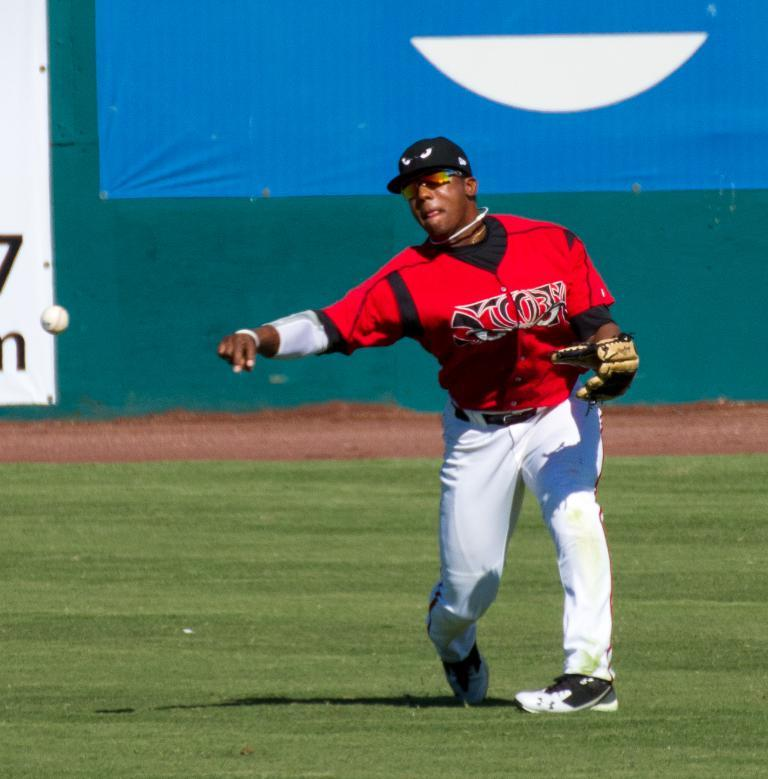What is the main subject of the image? There is a baseball player in the image. What is the baseball player doing in the image? The baseball player is standing on the ground and throwing a ball. What can be seen in the background of the image? There is a banner in the background of the image. What is visible at the bottom of the image? The ground is visible at the bottom of the image. What equipment is the baseball player wearing? The baseball player is wearing gloves. What type of impulse does the baseball player have to write in the notebook in the image? There is no notebook present in the image, and therefore no impulse for the baseball player to write. 